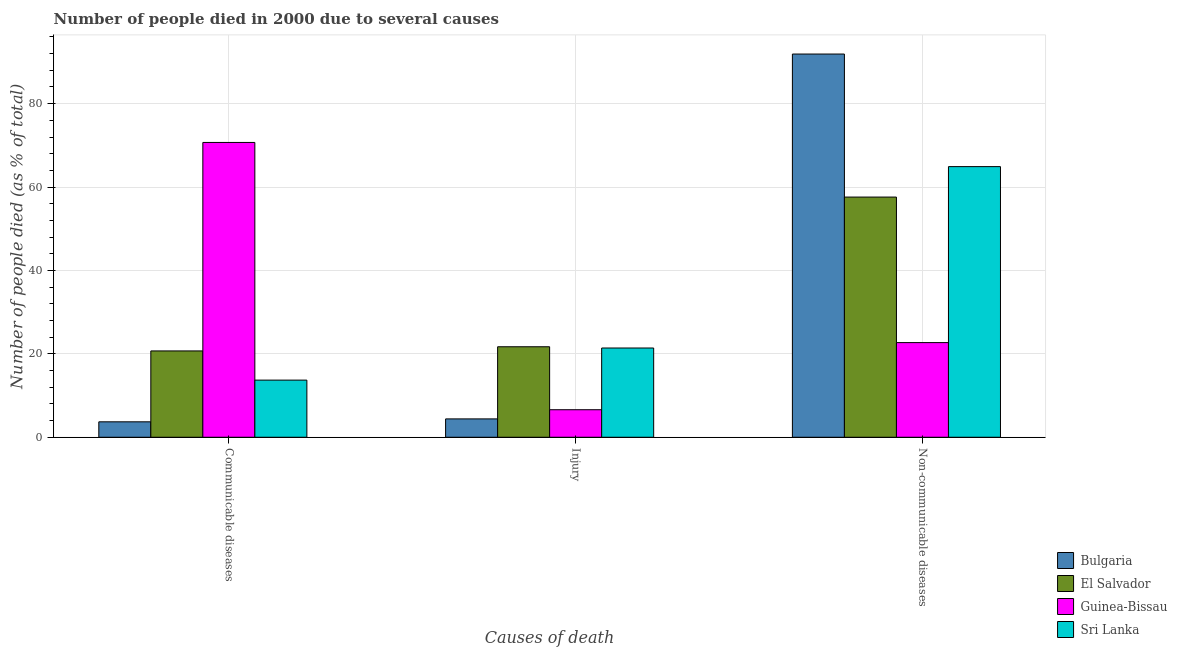How many groups of bars are there?
Make the answer very short. 3. How many bars are there on the 3rd tick from the right?
Offer a very short reply. 4. What is the label of the 3rd group of bars from the left?
Ensure brevity in your answer.  Non-communicable diseases. What is the number of people who dies of non-communicable diseases in Bulgaria?
Give a very brief answer. 91.9. Across all countries, what is the maximum number of people who died of communicable diseases?
Keep it short and to the point. 70.7. Across all countries, what is the minimum number of people who died of communicable diseases?
Give a very brief answer. 3.7. In which country was the number of people who died of communicable diseases maximum?
Offer a very short reply. Guinea-Bissau. In which country was the number of people who died of injury minimum?
Your answer should be compact. Bulgaria. What is the total number of people who died of communicable diseases in the graph?
Offer a terse response. 108.8. What is the difference between the number of people who dies of non-communicable diseases in Guinea-Bissau and that in Bulgaria?
Make the answer very short. -69.2. What is the difference between the number of people who died of injury in Guinea-Bissau and the number of people who died of communicable diseases in Bulgaria?
Keep it short and to the point. 2.9. What is the average number of people who died of communicable diseases per country?
Your response must be concise. 27.2. What is the ratio of the number of people who dies of non-communicable diseases in El Salvador to that in Guinea-Bissau?
Give a very brief answer. 2.54. Is the difference between the number of people who died of communicable diseases in Guinea-Bissau and Bulgaria greater than the difference between the number of people who died of injury in Guinea-Bissau and Bulgaria?
Ensure brevity in your answer.  Yes. What is the difference between the highest and the second highest number of people who died of injury?
Provide a short and direct response. 0.3. What is the difference between the highest and the lowest number of people who dies of non-communicable diseases?
Give a very brief answer. 69.2. In how many countries, is the number of people who died of communicable diseases greater than the average number of people who died of communicable diseases taken over all countries?
Provide a short and direct response. 1. What does the 3rd bar from the left in Injury represents?
Make the answer very short. Guinea-Bissau. What does the 2nd bar from the right in Non-communicable diseases represents?
Your answer should be very brief. Guinea-Bissau. How many bars are there?
Offer a terse response. 12. Are all the bars in the graph horizontal?
Offer a terse response. No. What is the difference between two consecutive major ticks on the Y-axis?
Provide a short and direct response. 20. Are the values on the major ticks of Y-axis written in scientific E-notation?
Give a very brief answer. No. How many legend labels are there?
Ensure brevity in your answer.  4. How are the legend labels stacked?
Your answer should be very brief. Vertical. What is the title of the graph?
Your response must be concise. Number of people died in 2000 due to several causes. What is the label or title of the X-axis?
Keep it short and to the point. Causes of death. What is the label or title of the Y-axis?
Ensure brevity in your answer.  Number of people died (as % of total). What is the Number of people died (as % of total) in El Salvador in Communicable diseases?
Make the answer very short. 20.7. What is the Number of people died (as % of total) of Guinea-Bissau in Communicable diseases?
Your response must be concise. 70.7. What is the Number of people died (as % of total) of Sri Lanka in Communicable diseases?
Make the answer very short. 13.7. What is the Number of people died (as % of total) of El Salvador in Injury?
Your answer should be compact. 21.7. What is the Number of people died (as % of total) in Sri Lanka in Injury?
Keep it short and to the point. 21.4. What is the Number of people died (as % of total) in Bulgaria in Non-communicable diseases?
Your response must be concise. 91.9. What is the Number of people died (as % of total) of El Salvador in Non-communicable diseases?
Provide a succinct answer. 57.6. What is the Number of people died (as % of total) in Guinea-Bissau in Non-communicable diseases?
Give a very brief answer. 22.7. What is the Number of people died (as % of total) in Sri Lanka in Non-communicable diseases?
Your answer should be compact. 64.9. Across all Causes of death, what is the maximum Number of people died (as % of total) in Bulgaria?
Provide a short and direct response. 91.9. Across all Causes of death, what is the maximum Number of people died (as % of total) of El Salvador?
Offer a terse response. 57.6. Across all Causes of death, what is the maximum Number of people died (as % of total) in Guinea-Bissau?
Ensure brevity in your answer.  70.7. Across all Causes of death, what is the maximum Number of people died (as % of total) in Sri Lanka?
Your response must be concise. 64.9. Across all Causes of death, what is the minimum Number of people died (as % of total) in Bulgaria?
Your answer should be very brief. 3.7. Across all Causes of death, what is the minimum Number of people died (as % of total) in El Salvador?
Offer a very short reply. 20.7. Across all Causes of death, what is the minimum Number of people died (as % of total) in Guinea-Bissau?
Keep it short and to the point. 6.6. What is the total Number of people died (as % of total) of Sri Lanka in the graph?
Make the answer very short. 100. What is the difference between the Number of people died (as % of total) in Bulgaria in Communicable diseases and that in Injury?
Provide a succinct answer. -0.7. What is the difference between the Number of people died (as % of total) of El Salvador in Communicable diseases and that in Injury?
Provide a succinct answer. -1. What is the difference between the Number of people died (as % of total) in Guinea-Bissau in Communicable diseases and that in Injury?
Your response must be concise. 64.1. What is the difference between the Number of people died (as % of total) of Bulgaria in Communicable diseases and that in Non-communicable diseases?
Keep it short and to the point. -88.2. What is the difference between the Number of people died (as % of total) in El Salvador in Communicable diseases and that in Non-communicable diseases?
Ensure brevity in your answer.  -36.9. What is the difference between the Number of people died (as % of total) in Sri Lanka in Communicable diseases and that in Non-communicable diseases?
Offer a very short reply. -51.2. What is the difference between the Number of people died (as % of total) of Bulgaria in Injury and that in Non-communicable diseases?
Your answer should be very brief. -87.5. What is the difference between the Number of people died (as % of total) of El Salvador in Injury and that in Non-communicable diseases?
Your answer should be very brief. -35.9. What is the difference between the Number of people died (as % of total) in Guinea-Bissau in Injury and that in Non-communicable diseases?
Make the answer very short. -16.1. What is the difference between the Number of people died (as % of total) of Sri Lanka in Injury and that in Non-communicable diseases?
Provide a short and direct response. -43.5. What is the difference between the Number of people died (as % of total) of Bulgaria in Communicable diseases and the Number of people died (as % of total) of El Salvador in Injury?
Give a very brief answer. -18. What is the difference between the Number of people died (as % of total) in Bulgaria in Communicable diseases and the Number of people died (as % of total) in Sri Lanka in Injury?
Make the answer very short. -17.7. What is the difference between the Number of people died (as % of total) of El Salvador in Communicable diseases and the Number of people died (as % of total) of Guinea-Bissau in Injury?
Offer a terse response. 14.1. What is the difference between the Number of people died (as % of total) of El Salvador in Communicable diseases and the Number of people died (as % of total) of Sri Lanka in Injury?
Your answer should be compact. -0.7. What is the difference between the Number of people died (as % of total) in Guinea-Bissau in Communicable diseases and the Number of people died (as % of total) in Sri Lanka in Injury?
Offer a terse response. 49.3. What is the difference between the Number of people died (as % of total) of Bulgaria in Communicable diseases and the Number of people died (as % of total) of El Salvador in Non-communicable diseases?
Make the answer very short. -53.9. What is the difference between the Number of people died (as % of total) in Bulgaria in Communicable diseases and the Number of people died (as % of total) in Sri Lanka in Non-communicable diseases?
Offer a terse response. -61.2. What is the difference between the Number of people died (as % of total) in El Salvador in Communicable diseases and the Number of people died (as % of total) in Sri Lanka in Non-communicable diseases?
Give a very brief answer. -44.2. What is the difference between the Number of people died (as % of total) of Bulgaria in Injury and the Number of people died (as % of total) of El Salvador in Non-communicable diseases?
Offer a terse response. -53.2. What is the difference between the Number of people died (as % of total) of Bulgaria in Injury and the Number of people died (as % of total) of Guinea-Bissau in Non-communicable diseases?
Ensure brevity in your answer.  -18.3. What is the difference between the Number of people died (as % of total) in Bulgaria in Injury and the Number of people died (as % of total) in Sri Lanka in Non-communicable diseases?
Provide a succinct answer. -60.5. What is the difference between the Number of people died (as % of total) of El Salvador in Injury and the Number of people died (as % of total) of Sri Lanka in Non-communicable diseases?
Offer a very short reply. -43.2. What is the difference between the Number of people died (as % of total) in Guinea-Bissau in Injury and the Number of people died (as % of total) in Sri Lanka in Non-communicable diseases?
Your answer should be very brief. -58.3. What is the average Number of people died (as % of total) in Bulgaria per Causes of death?
Offer a terse response. 33.33. What is the average Number of people died (as % of total) in El Salvador per Causes of death?
Ensure brevity in your answer.  33.33. What is the average Number of people died (as % of total) in Guinea-Bissau per Causes of death?
Provide a short and direct response. 33.33. What is the average Number of people died (as % of total) in Sri Lanka per Causes of death?
Make the answer very short. 33.33. What is the difference between the Number of people died (as % of total) of Bulgaria and Number of people died (as % of total) of Guinea-Bissau in Communicable diseases?
Keep it short and to the point. -67. What is the difference between the Number of people died (as % of total) of Bulgaria and Number of people died (as % of total) of Sri Lanka in Communicable diseases?
Your answer should be compact. -10. What is the difference between the Number of people died (as % of total) of El Salvador and Number of people died (as % of total) of Sri Lanka in Communicable diseases?
Offer a terse response. 7. What is the difference between the Number of people died (as % of total) of Bulgaria and Number of people died (as % of total) of El Salvador in Injury?
Provide a succinct answer. -17.3. What is the difference between the Number of people died (as % of total) in El Salvador and Number of people died (as % of total) in Guinea-Bissau in Injury?
Provide a short and direct response. 15.1. What is the difference between the Number of people died (as % of total) in El Salvador and Number of people died (as % of total) in Sri Lanka in Injury?
Offer a very short reply. 0.3. What is the difference between the Number of people died (as % of total) of Guinea-Bissau and Number of people died (as % of total) of Sri Lanka in Injury?
Ensure brevity in your answer.  -14.8. What is the difference between the Number of people died (as % of total) of Bulgaria and Number of people died (as % of total) of El Salvador in Non-communicable diseases?
Your answer should be compact. 34.3. What is the difference between the Number of people died (as % of total) in Bulgaria and Number of people died (as % of total) in Guinea-Bissau in Non-communicable diseases?
Provide a succinct answer. 69.2. What is the difference between the Number of people died (as % of total) of El Salvador and Number of people died (as % of total) of Guinea-Bissau in Non-communicable diseases?
Your answer should be compact. 34.9. What is the difference between the Number of people died (as % of total) in Guinea-Bissau and Number of people died (as % of total) in Sri Lanka in Non-communicable diseases?
Give a very brief answer. -42.2. What is the ratio of the Number of people died (as % of total) of Bulgaria in Communicable diseases to that in Injury?
Keep it short and to the point. 0.84. What is the ratio of the Number of people died (as % of total) in El Salvador in Communicable diseases to that in Injury?
Offer a terse response. 0.95. What is the ratio of the Number of people died (as % of total) of Guinea-Bissau in Communicable diseases to that in Injury?
Provide a succinct answer. 10.71. What is the ratio of the Number of people died (as % of total) of Sri Lanka in Communicable diseases to that in Injury?
Your answer should be compact. 0.64. What is the ratio of the Number of people died (as % of total) of Bulgaria in Communicable diseases to that in Non-communicable diseases?
Ensure brevity in your answer.  0.04. What is the ratio of the Number of people died (as % of total) of El Salvador in Communicable diseases to that in Non-communicable diseases?
Ensure brevity in your answer.  0.36. What is the ratio of the Number of people died (as % of total) of Guinea-Bissau in Communicable diseases to that in Non-communicable diseases?
Provide a short and direct response. 3.11. What is the ratio of the Number of people died (as % of total) of Sri Lanka in Communicable diseases to that in Non-communicable diseases?
Make the answer very short. 0.21. What is the ratio of the Number of people died (as % of total) of Bulgaria in Injury to that in Non-communicable diseases?
Offer a very short reply. 0.05. What is the ratio of the Number of people died (as % of total) in El Salvador in Injury to that in Non-communicable diseases?
Provide a short and direct response. 0.38. What is the ratio of the Number of people died (as % of total) in Guinea-Bissau in Injury to that in Non-communicable diseases?
Your response must be concise. 0.29. What is the ratio of the Number of people died (as % of total) in Sri Lanka in Injury to that in Non-communicable diseases?
Keep it short and to the point. 0.33. What is the difference between the highest and the second highest Number of people died (as % of total) in Bulgaria?
Offer a terse response. 87.5. What is the difference between the highest and the second highest Number of people died (as % of total) of El Salvador?
Your answer should be very brief. 35.9. What is the difference between the highest and the second highest Number of people died (as % of total) of Guinea-Bissau?
Offer a very short reply. 48. What is the difference between the highest and the second highest Number of people died (as % of total) in Sri Lanka?
Your answer should be compact. 43.5. What is the difference between the highest and the lowest Number of people died (as % of total) in Bulgaria?
Provide a succinct answer. 88.2. What is the difference between the highest and the lowest Number of people died (as % of total) in El Salvador?
Offer a terse response. 36.9. What is the difference between the highest and the lowest Number of people died (as % of total) in Guinea-Bissau?
Your answer should be very brief. 64.1. What is the difference between the highest and the lowest Number of people died (as % of total) in Sri Lanka?
Offer a very short reply. 51.2. 